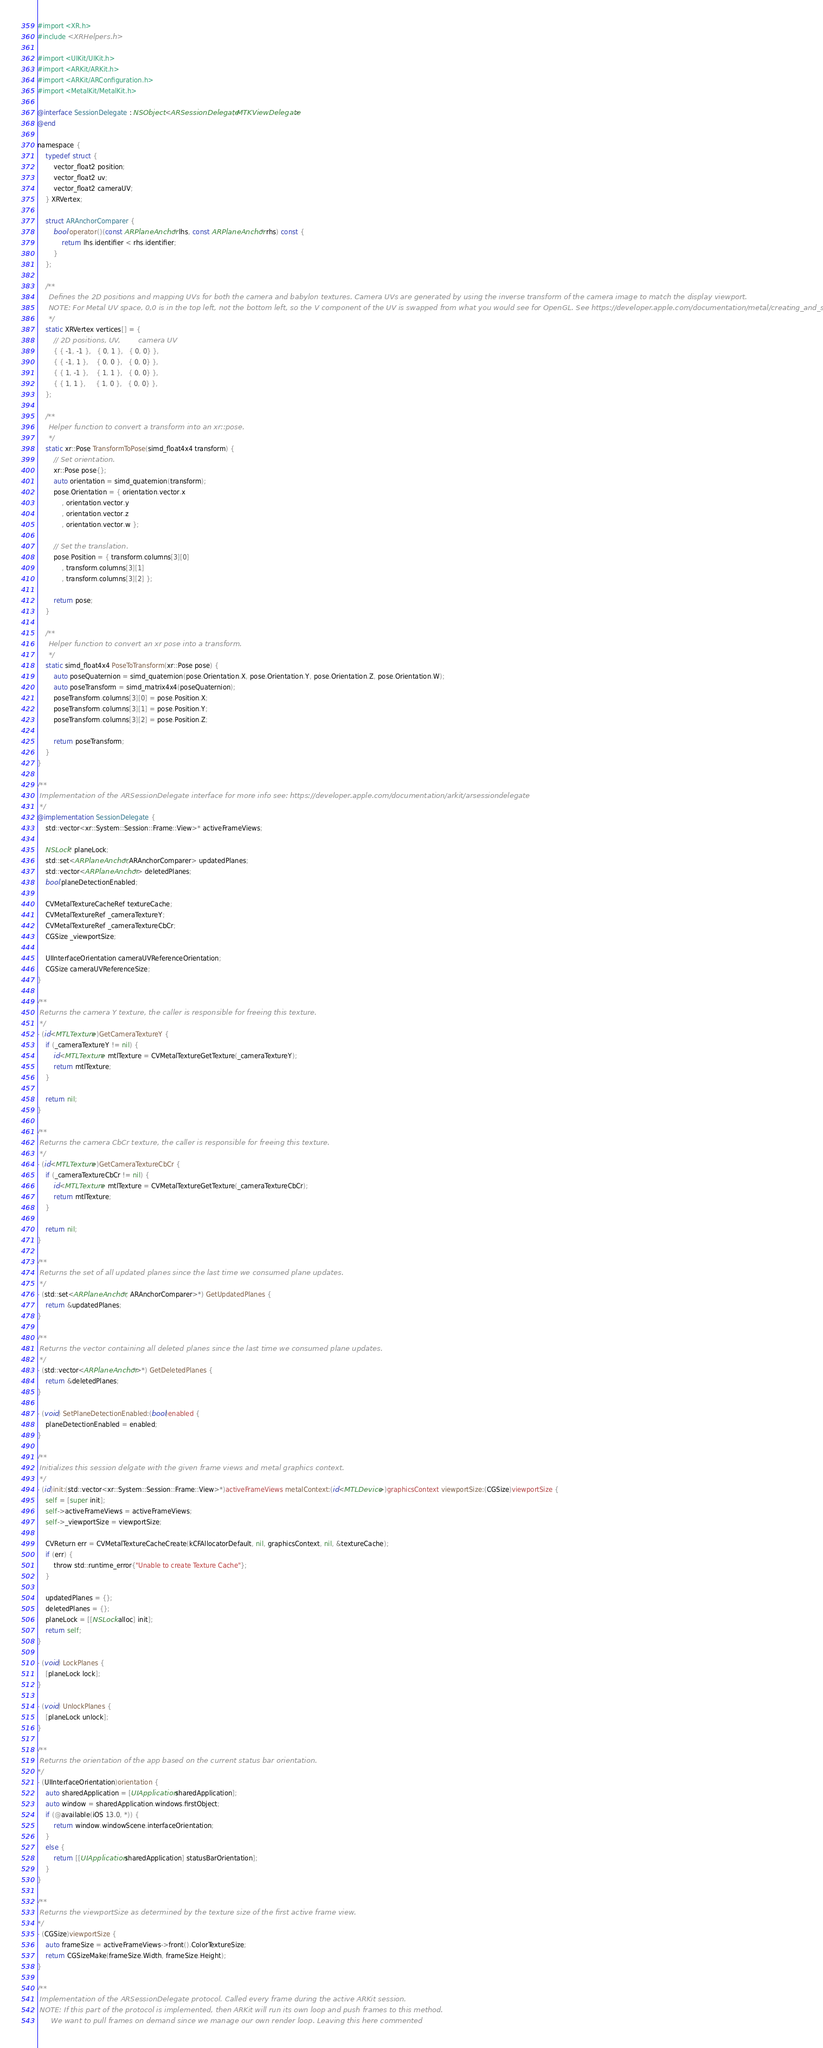<code> <loc_0><loc_0><loc_500><loc_500><_ObjectiveC_>#import <XR.h>
#include <XRHelpers.h>

#import <UIKit/UIKit.h>
#import <ARKit/ARKit.h>
#import <ARKit/ARConfiguration.h>
#import <MetalKit/MetalKit.h>

@interface SessionDelegate : NSObject <ARSessionDelegate, MTKViewDelegate>
@end

namespace {
    typedef struct {
        vector_float2 position;
        vector_float2 uv;
        vector_float2 cameraUV;
    } XRVertex;

    struct ARAnchorComparer {
        bool operator()(const ARPlaneAnchor* lhs, const ARPlaneAnchor* rhs) const {
            return lhs.identifier < rhs.identifier;
        }
    };

    /**
     Defines the 2D positions and mapping UVs for both the camera and babylon textures. Camera UVs are generated by using the inverse transform of the camera image to match the display viewport.
     NOTE: For Metal UV space, 0,0 is in the top left, not the bottom left, so the V component of the UV is swapped from what you would see for OpenGL. See https://developer.apple.com/documentation/metal/creating_and_sampling_textures.
     */
    static XRVertex vertices[] = {
        // 2D positions, UV,        camera UV
        { { -1, -1 },   { 0, 1 },   { 0, 0} },
        { { -1, 1 },    { 0, 0 },   { 0, 0} },
        { { 1, -1 },    { 1, 1 },   { 0, 0} },
        { { 1, 1 },     { 1, 0 },   { 0, 0} },
    };

    /**
     Helper function to convert a transform into an xr::pose.
     */
    static xr::Pose TransformToPose(simd_float4x4 transform) {
        // Set orientation.
        xr::Pose pose{};
        auto orientation = simd_quaternion(transform);
        pose.Orientation = { orientation.vector.x
            , orientation.vector.y
            , orientation.vector.z
            , orientation.vector.w };

        // Set the translation.
        pose.Position = { transform.columns[3][0]
            , transform.columns[3][1]
            , transform.columns[3][2] };

        return pose;
    }

    /**
     Helper function to convert an xr pose into a transform.
     */
    static simd_float4x4 PoseToTransform(xr::Pose pose) {
        auto poseQuaternion = simd_quaternion(pose.Orientation.X, pose.Orientation.Y, pose.Orientation.Z, pose.Orientation.W);
        auto poseTransform = simd_matrix4x4(poseQuaternion);
        poseTransform.columns[3][0] = pose.Position.X;
        poseTransform.columns[3][1] = pose.Position.Y;
        poseTransform.columns[3][2] = pose.Position.Z;

        return poseTransform;
    }
}

/**
 Implementation of the ARSessionDelegate interface for more info see: https://developer.apple.com/documentation/arkit/arsessiondelegate
 */
@implementation SessionDelegate {
    std::vector<xr::System::Session::Frame::View>* activeFrameViews;

    NSLock* planeLock;
    std::set<ARPlaneAnchor*,ARAnchorComparer> updatedPlanes;
    std::vector<ARPlaneAnchor*> deletedPlanes;
    bool planeDetectionEnabled;

    CVMetalTextureCacheRef textureCache;
    CVMetalTextureRef _cameraTextureY;
    CVMetalTextureRef _cameraTextureCbCr;
    CGSize _viewportSize;

    UIInterfaceOrientation cameraUVReferenceOrientation;
    CGSize cameraUVReferenceSize;
}

/**
 Returns the camera Y texture, the caller is responsible for freeing this texture.
 */
- (id<MTLTexture>)GetCameraTextureY {
    if (_cameraTextureY != nil) {
        id<MTLTexture> mtlTexture = CVMetalTextureGetTexture(_cameraTextureY);
        return mtlTexture;
    }

    return nil;
}

/**
 Returns the camera CbCr texture, the caller is responsible for freeing this texture.
 */
- (id<MTLTexture>)GetCameraTextureCbCr {
    if (_cameraTextureCbCr != nil) {
        id<MTLTexture> mtlTexture = CVMetalTextureGetTexture(_cameraTextureCbCr);
        return mtlTexture;
    }

    return nil;
}

/**
 Returns the set of all updated planes since the last time we consumed plane updates.
 */
- (std::set<ARPlaneAnchor*, ARAnchorComparer>*) GetUpdatedPlanes {
    return &updatedPlanes;
}

/**
 Returns the vector containing all deleted planes since the last time we consumed plane updates.
 */
- (std::vector<ARPlaneAnchor*>*) GetDeletedPlanes {
    return &deletedPlanes;
}

- (void) SetPlaneDetectionEnabled:(bool)enabled {
    planeDetectionEnabled = enabled;
}

/**
 Initializes this session delgate with the given frame views and metal graphics context.
 */
- (id)init:(std::vector<xr::System::Session::Frame::View>*)activeFrameViews metalContext:(id<MTLDevice>)graphicsContext viewportSize:(CGSize)viewportSize {
    self = [super init];
    self->activeFrameViews = activeFrameViews;
    self->_viewportSize = viewportSize;

    CVReturn err = CVMetalTextureCacheCreate(kCFAllocatorDefault, nil, graphicsContext, nil, &textureCache);
    if (err) {
        throw std::runtime_error{"Unable to create Texture Cache"};
    }

    updatedPlanes = {};
    deletedPlanes = {};
    planeLock = [[NSLock alloc] init];
    return self;
}

- (void) LockPlanes {
    [planeLock lock];
}

- (void) UnlockPlanes {
    [planeLock unlock];
}

/**
 Returns the orientation of the app based on the current status bar orientation.
*/
- (UIInterfaceOrientation)orientation {
    auto sharedApplication = [UIApplication sharedApplication];
    auto window = sharedApplication.windows.firstObject;
    if (@available(iOS 13.0, *)) {
        return window.windowScene.interfaceOrientation;
    }
    else {
        return [[UIApplication sharedApplication] statusBarOrientation];
    }
}

/**
 Returns the viewportSize as determined by the texture size of the first active frame view.
*/
- (CGSize)viewportSize {
    auto frameSize = activeFrameViews->front().ColorTextureSize;
    return CGSizeMake(frameSize.Width, frameSize.Height);
}

/**
 Implementation of the ARSessionDelegate protocol. Called every frame during the active ARKit session.
 NOTE: If this part of the protocol is implemented, then ARKit will run its own loop and push frames to this method.
      We want to pull frames on demand since we manage our own render loop. Leaving this here commented</code> 